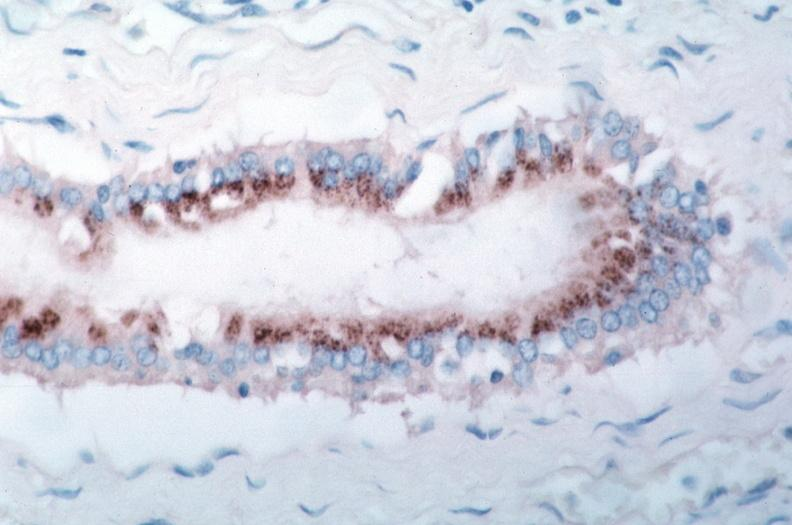what is vasculitis , rocky mountain spotted?
Answer the question using a single word or phrase. Fever immunoperoxidase staining vessels for rickettsia rickettsii 